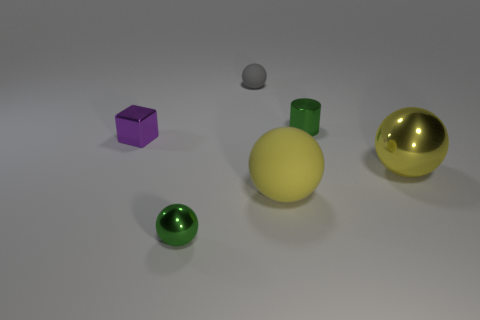Subtract 1 spheres. How many spheres are left? 3 Add 4 tiny green balls. How many objects exist? 10 Subtract all cylinders. How many objects are left? 5 Subtract all blocks. Subtract all big spheres. How many objects are left? 3 Add 5 small green metallic balls. How many small green metallic balls are left? 6 Add 5 metallic balls. How many metallic balls exist? 7 Subtract 0 blue cubes. How many objects are left? 6 